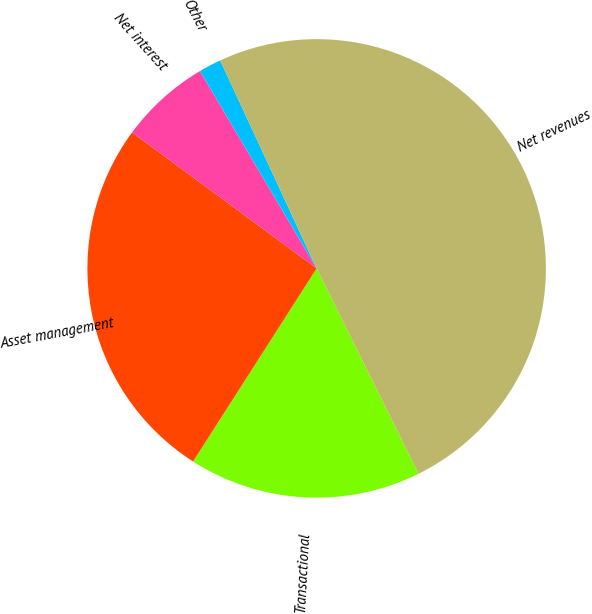Convert chart. <chart><loc_0><loc_0><loc_500><loc_500><pie_chart><fcel>Transactional<fcel>Asset management<fcel>Net interest<fcel>Other<fcel>Net revenues<nl><fcel>16.39%<fcel>26.05%<fcel>6.39%<fcel>1.59%<fcel>49.58%<nl></chart> 